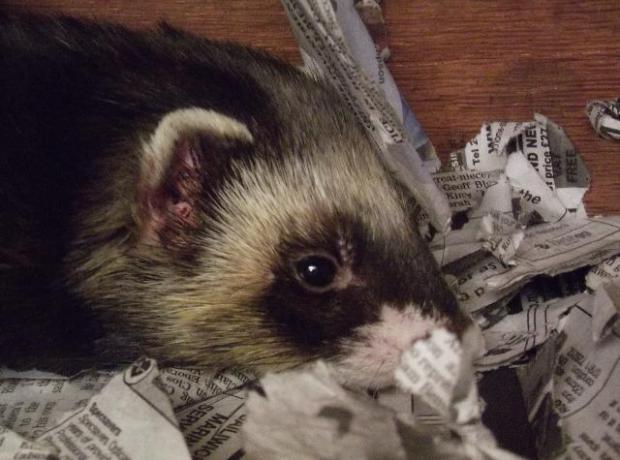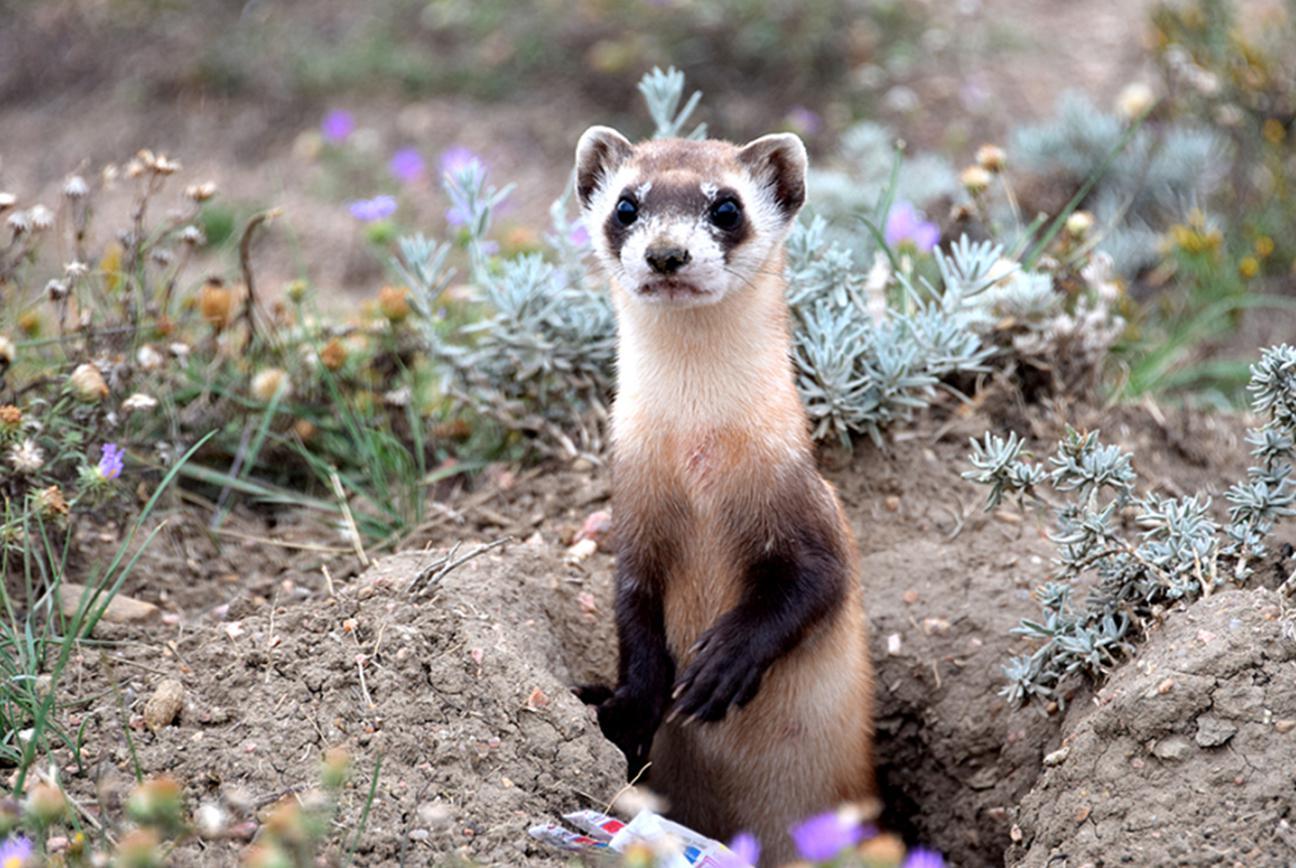The first image is the image on the left, the second image is the image on the right. Examine the images to the left and right. Is the description "The right image contains one ferret emerging from a hole in the dirt." accurate? Answer yes or no. Yes. 